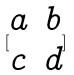Convert formula to latex. <formula><loc_0><loc_0><loc_500><loc_500>[ \begin{matrix} a & b \\ c & d \\ \end{matrix} ]</formula> 